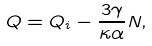<formula> <loc_0><loc_0><loc_500><loc_500>Q = Q _ { i } - \frac { 3 \gamma } { \kappa \alpha } N ,</formula> 